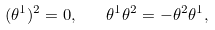<formula> <loc_0><loc_0><loc_500><loc_500>( \theta ^ { 1 } ) ^ { 2 } = 0 , \quad \theta ^ { 1 } \theta ^ { 2 } = - \theta ^ { 2 } \theta ^ { 1 } ,</formula> 